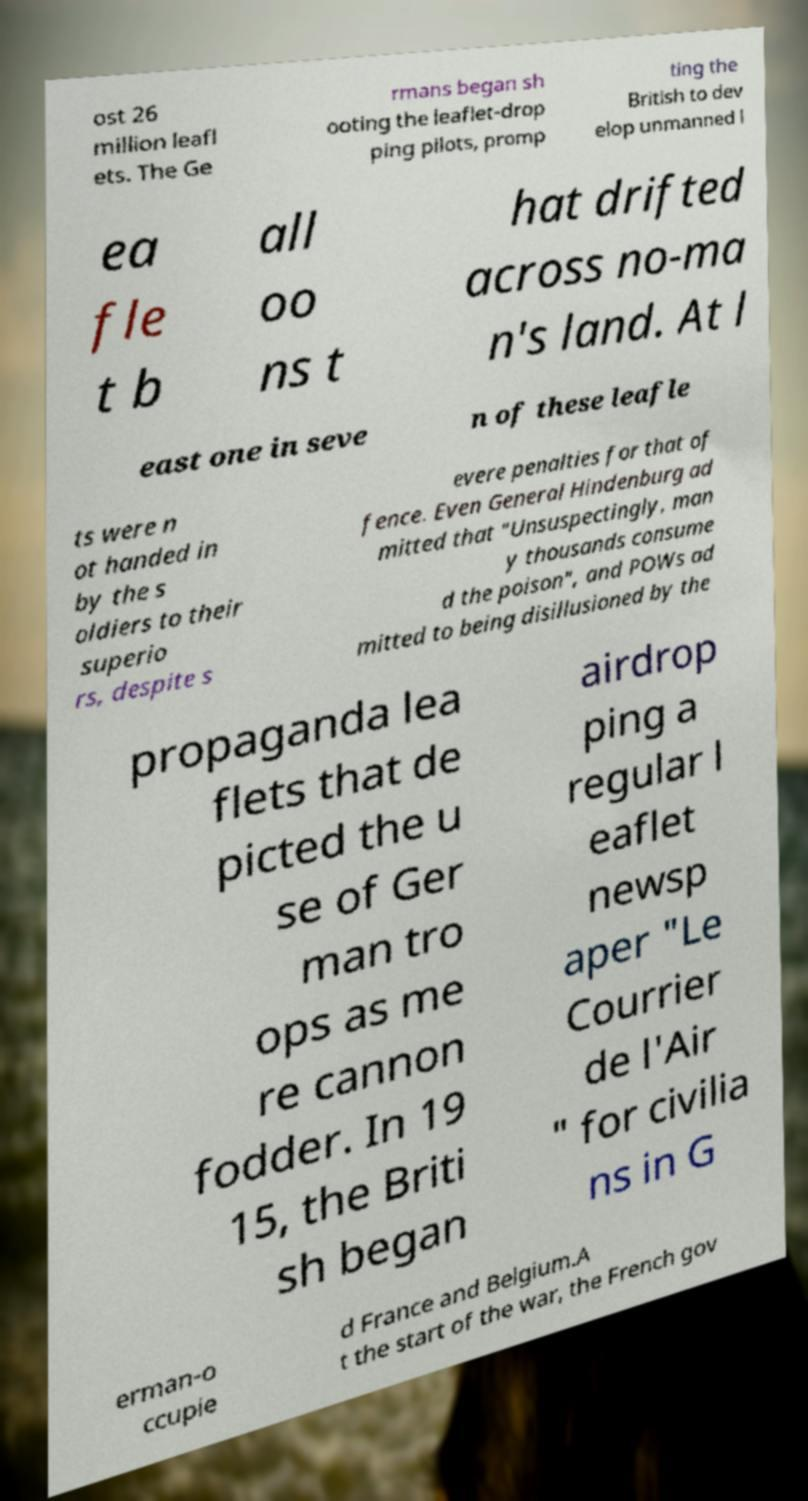Could you assist in decoding the text presented in this image and type it out clearly? ost 26 million leafl ets. The Ge rmans began sh ooting the leaflet-drop ping pilots, promp ting the British to dev elop unmanned l ea fle t b all oo ns t hat drifted across no-ma n's land. At l east one in seve n of these leafle ts were n ot handed in by the s oldiers to their superio rs, despite s evere penalties for that of fence. Even General Hindenburg ad mitted that "Unsuspectingly, man y thousands consume d the poison", and POWs ad mitted to being disillusioned by the propaganda lea flets that de picted the u se of Ger man tro ops as me re cannon fodder. In 19 15, the Briti sh began airdrop ping a regular l eaflet newsp aper "Le Courrier de l'Air " for civilia ns in G erman-o ccupie d France and Belgium.A t the start of the war, the French gov 